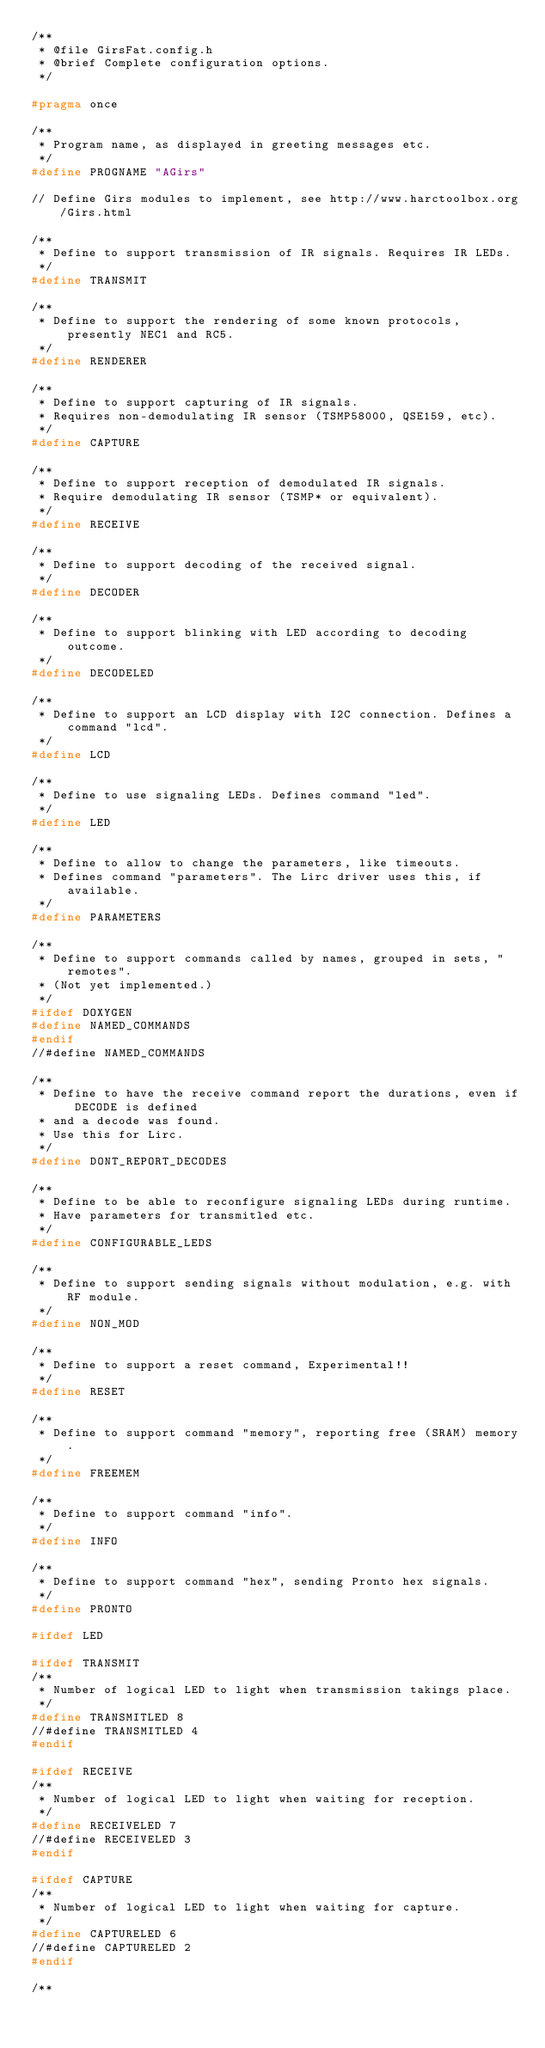<code> <loc_0><loc_0><loc_500><loc_500><_C_>/**
 * @file GirsFat.config.h
 * @brief Complete configuration options.
 */

#pragma once

/**
 * Program name, as displayed in greeting messages etc.
 */
#define PROGNAME "AGirs"

// Define Girs modules to implement, see http://www.harctoolbox.org/Girs.html

/**
 * Define to support transmission of IR signals. Requires IR LEDs.
 */
#define TRANSMIT

/**
 * Define to support the rendering of some known protocols, presently NEC1 and RC5.
 */
#define RENDERER

/**
 * Define to support capturing of IR signals.
 * Requires non-demodulating IR sensor (TSMP58000, QSE159, etc).
 */
#define CAPTURE

/**
 * Define to support reception of demodulated IR signals.
 * Require demodulating IR sensor (TSMP* or equivalent).
 */
#define RECEIVE

/**
 * Define to support decoding of the received signal.
 */
#define DECODER

/**
 * Define to support blinking with LED according to decoding outcome.
 */
#define DECODELED

/**
 * Define to support an LCD display with I2C connection. Defines a command "lcd".
 */
#define LCD

/**
 * Define to use signaling LEDs. Defines command "led".
 */
#define LED

/**
 * Define to allow to change the parameters, like timeouts.
 * Defines command "parameters". The Lirc driver uses this, if available.
 */
#define PARAMETERS

/**
 * Define to support commands called by names, grouped in sets, "remotes".
 * (Not yet implemented.)
 */
#ifdef DOXYGEN
#define NAMED_COMMANDS
#endif
//#define NAMED_COMMANDS

/**
 * Define to have the receive command report the durations, even if DECODE is defined
 * and a decode was found.
 * Use this for Lirc.
 */
#define DONT_REPORT_DECODES

/**
 * Define to be able to reconfigure signaling LEDs during runtime.
 * Have parameters for transmitled etc.
 */
#define CONFIGURABLE_LEDS

/**
 * Define to support sending signals without modulation, e.g. with RF module.
 */
#define NON_MOD

/**
 * Define to support a reset command, Experimental!!
 */
#define RESET

/**
 * Define to support command "memory", reporting free (SRAM) memory.
 */
#define FREEMEM

/**
 * Define to support command "info".
 */
#define INFO

/**
 * Define to support command "hex", sending Pronto hex signals.
 */
#define PRONTO

#ifdef LED

#ifdef TRANSMIT
/**
 * Number of logical LED to light when transmission takings place.
 */
#define TRANSMITLED 8
//#define TRANSMITLED 4
#endif

#ifdef RECEIVE
/**
 * Number of logical LED to light when waiting for reception.
 */
#define RECEIVELED 7
//#define RECEIVELED 3
#endif

#ifdef CAPTURE
/**
 * Number of logical LED to light when waiting for capture.
 */
#define CAPTURELED 6
//#define CAPTURELED 2
#endif

/**</code> 